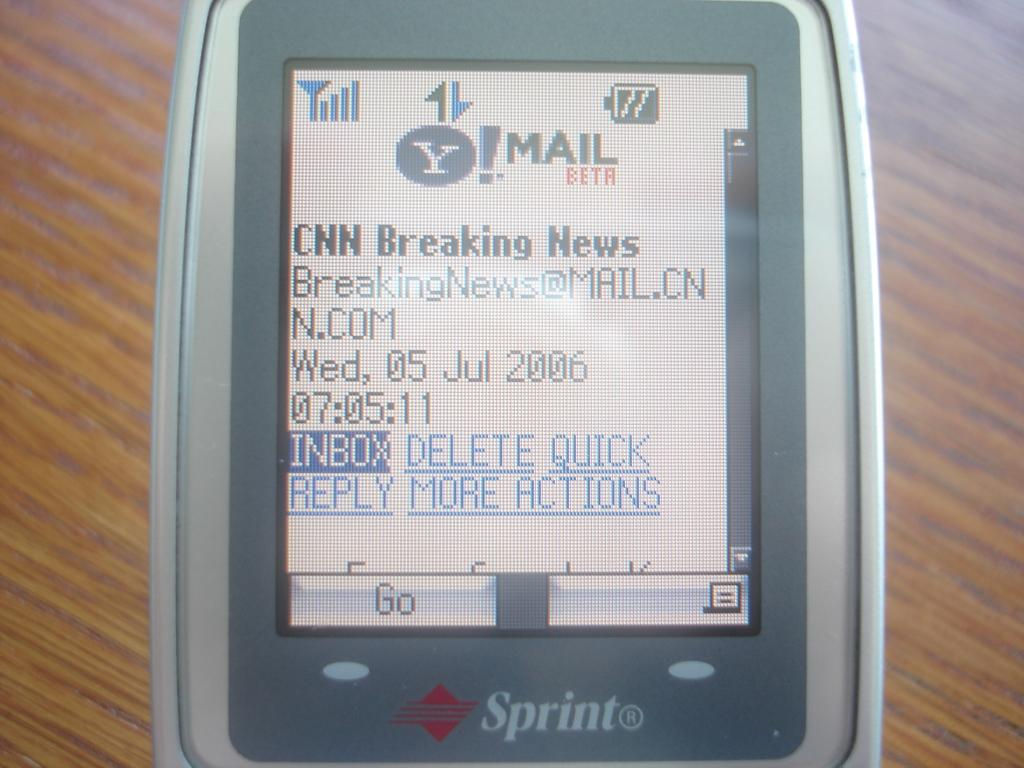<image>
Provide a brief description of the given image. An old Sprint phone shows some breaking news from CNN on the screen. 